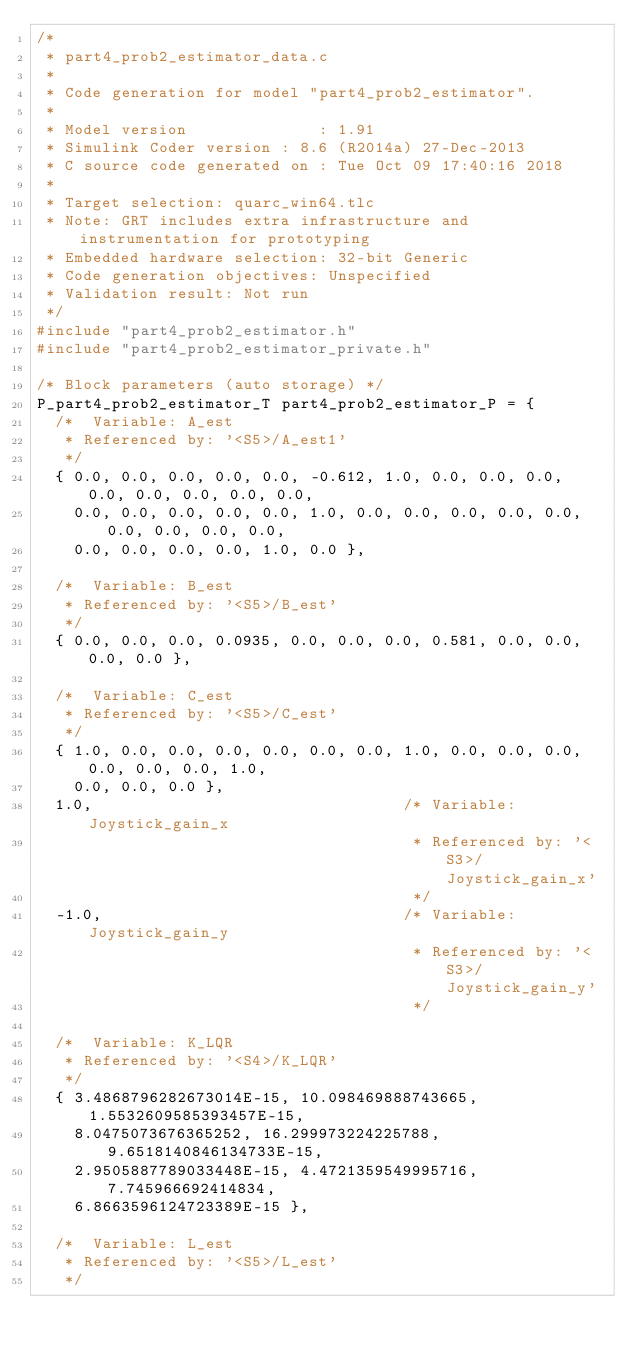<code> <loc_0><loc_0><loc_500><loc_500><_C_>/*
 * part4_prob2_estimator_data.c
 *
 * Code generation for model "part4_prob2_estimator".
 *
 * Model version              : 1.91
 * Simulink Coder version : 8.6 (R2014a) 27-Dec-2013
 * C source code generated on : Tue Oct 09 17:40:16 2018
 *
 * Target selection: quarc_win64.tlc
 * Note: GRT includes extra infrastructure and instrumentation for prototyping
 * Embedded hardware selection: 32-bit Generic
 * Code generation objectives: Unspecified
 * Validation result: Not run
 */
#include "part4_prob2_estimator.h"
#include "part4_prob2_estimator_private.h"

/* Block parameters (auto storage) */
P_part4_prob2_estimator_T part4_prob2_estimator_P = {
  /*  Variable: A_est
   * Referenced by: '<S5>/A_est1'
   */
  { 0.0, 0.0, 0.0, 0.0, 0.0, -0.612, 1.0, 0.0, 0.0, 0.0, 0.0, 0.0, 0.0, 0.0, 0.0,
    0.0, 0.0, 0.0, 0.0, 0.0, 1.0, 0.0, 0.0, 0.0, 0.0, 0.0, 0.0, 0.0, 0.0, 0.0,
    0.0, 0.0, 0.0, 0.0, 1.0, 0.0 },

  /*  Variable: B_est
   * Referenced by: '<S5>/B_est'
   */
  { 0.0, 0.0, 0.0, 0.0935, 0.0, 0.0, 0.0, 0.581, 0.0, 0.0, 0.0, 0.0 },

  /*  Variable: C_est
   * Referenced by: '<S5>/C_est'
   */
  { 1.0, 0.0, 0.0, 0.0, 0.0, 0.0, 0.0, 1.0, 0.0, 0.0, 0.0, 0.0, 0.0, 0.0, 1.0,
    0.0, 0.0, 0.0 },
  1.0,                                 /* Variable: Joystick_gain_x
                                        * Referenced by: '<S3>/Joystick_gain_x'
                                        */
  -1.0,                                /* Variable: Joystick_gain_y
                                        * Referenced by: '<S3>/Joystick_gain_y'
                                        */

  /*  Variable: K_LQR
   * Referenced by: '<S4>/K_LQR'
   */
  { 3.4868796282673014E-15, 10.098469888743665, 1.5532609585393457E-15,
    8.0475073676365252, 16.299973224225788, 9.6518140846134733E-15,
    2.9505887789033448E-15, 4.4721359549995716, 7.745966692414834,
    6.8663596124723389E-15 },

  /*  Variable: L_est
   * Referenced by: '<S5>/L_est'
   */</code> 